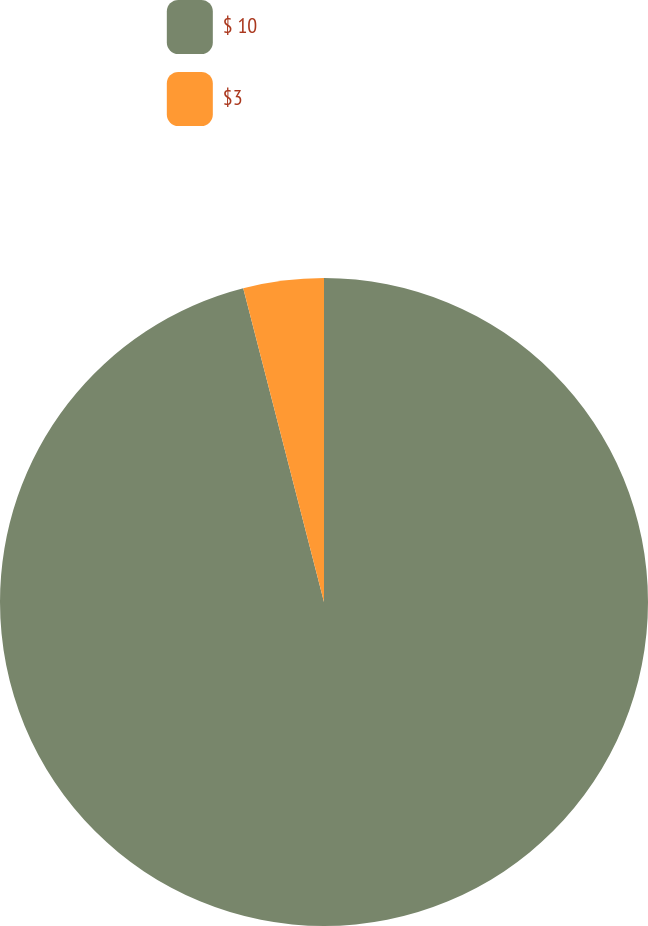<chart> <loc_0><loc_0><loc_500><loc_500><pie_chart><fcel>$ 10<fcel>$3<nl><fcel>95.99%<fcel>4.01%<nl></chart> 